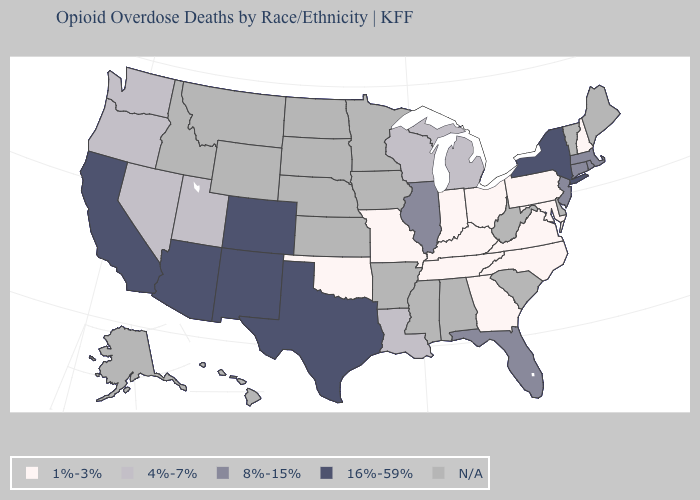Name the states that have a value in the range 1%-3%?
Concise answer only. Georgia, Indiana, Kentucky, Maryland, Missouri, New Hampshire, North Carolina, Ohio, Oklahoma, Pennsylvania, Tennessee, Virginia. What is the value of Ohio?
Quick response, please. 1%-3%. What is the value of Arizona?
Give a very brief answer. 16%-59%. What is the value of Nevada?
Concise answer only. 4%-7%. What is the value of California?
Answer briefly. 16%-59%. Which states hav the highest value in the MidWest?
Give a very brief answer. Illinois. What is the highest value in states that border Ohio?
Short answer required. 4%-7%. What is the value of Oregon?
Quick response, please. 4%-7%. What is the highest value in states that border New York?
Be succinct. 8%-15%. What is the value of North Dakota?
Write a very short answer. N/A. Name the states that have a value in the range 1%-3%?
Be succinct. Georgia, Indiana, Kentucky, Maryland, Missouri, New Hampshire, North Carolina, Ohio, Oklahoma, Pennsylvania, Tennessee, Virginia. Does Indiana have the lowest value in the MidWest?
Concise answer only. Yes. How many symbols are there in the legend?
Keep it brief. 5. 